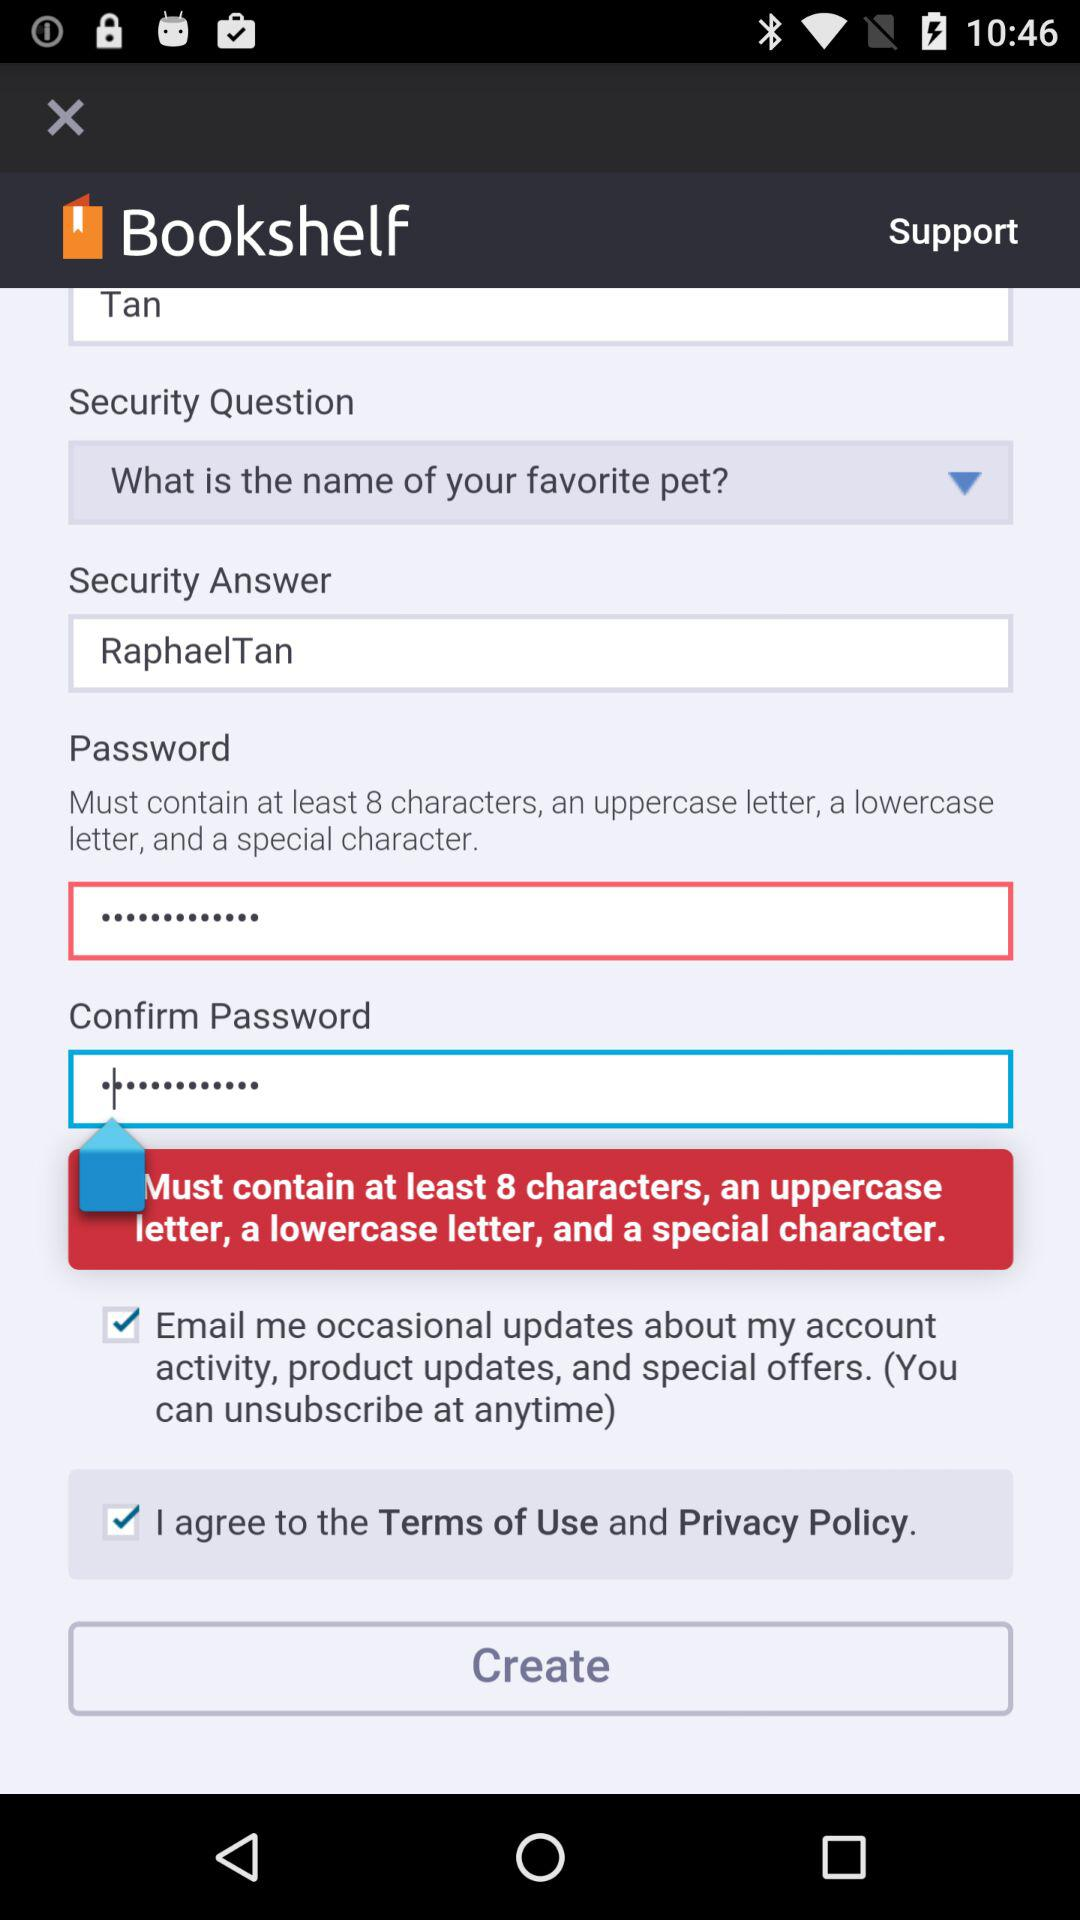What is the security answer? The security answer is "RaphaelTan". 